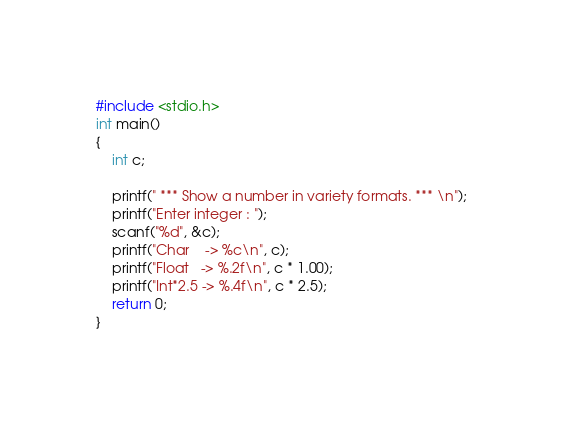Convert code to text. <code><loc_0><loc_0><loc_500><loc_500><_C_>#include <stdio.h>
int main()
{
    int c;

    printf(" *** Show a number in variety formats. *** \n");
    printf("Enter integer : ");
    scanf("%d", &c);
    printf("Char    -> %c\n", c);
    printf("Float   -> %.2f\n", c * 1.00);
    printf("Int*2.5 -> %.4f\n", c * 2.5);
    return 0;
}</code> 